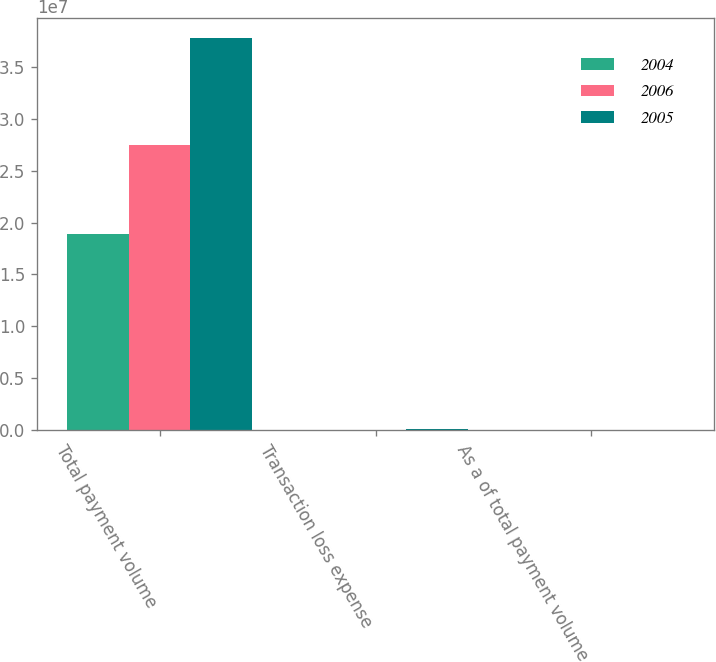Convert chart to OTSL. <chart><loc_0><loc_0><loc_500><loc_500><stacked_bar_chart><ecel><fcel>Total payment volume<fcel>Transaction loss expense<fcel>As a of total payment volume<nl><fcel>2004<fcel>1.8915e+07<fcel>50459<fcel>0.27<nl><fcel>2006<fcel>2.7485e+07<fcel>73773<fcel>0.27<nl><fcel>2005<fcel>3.7752e+07<fcel>126439<fcel>0.33<nl></chart> 